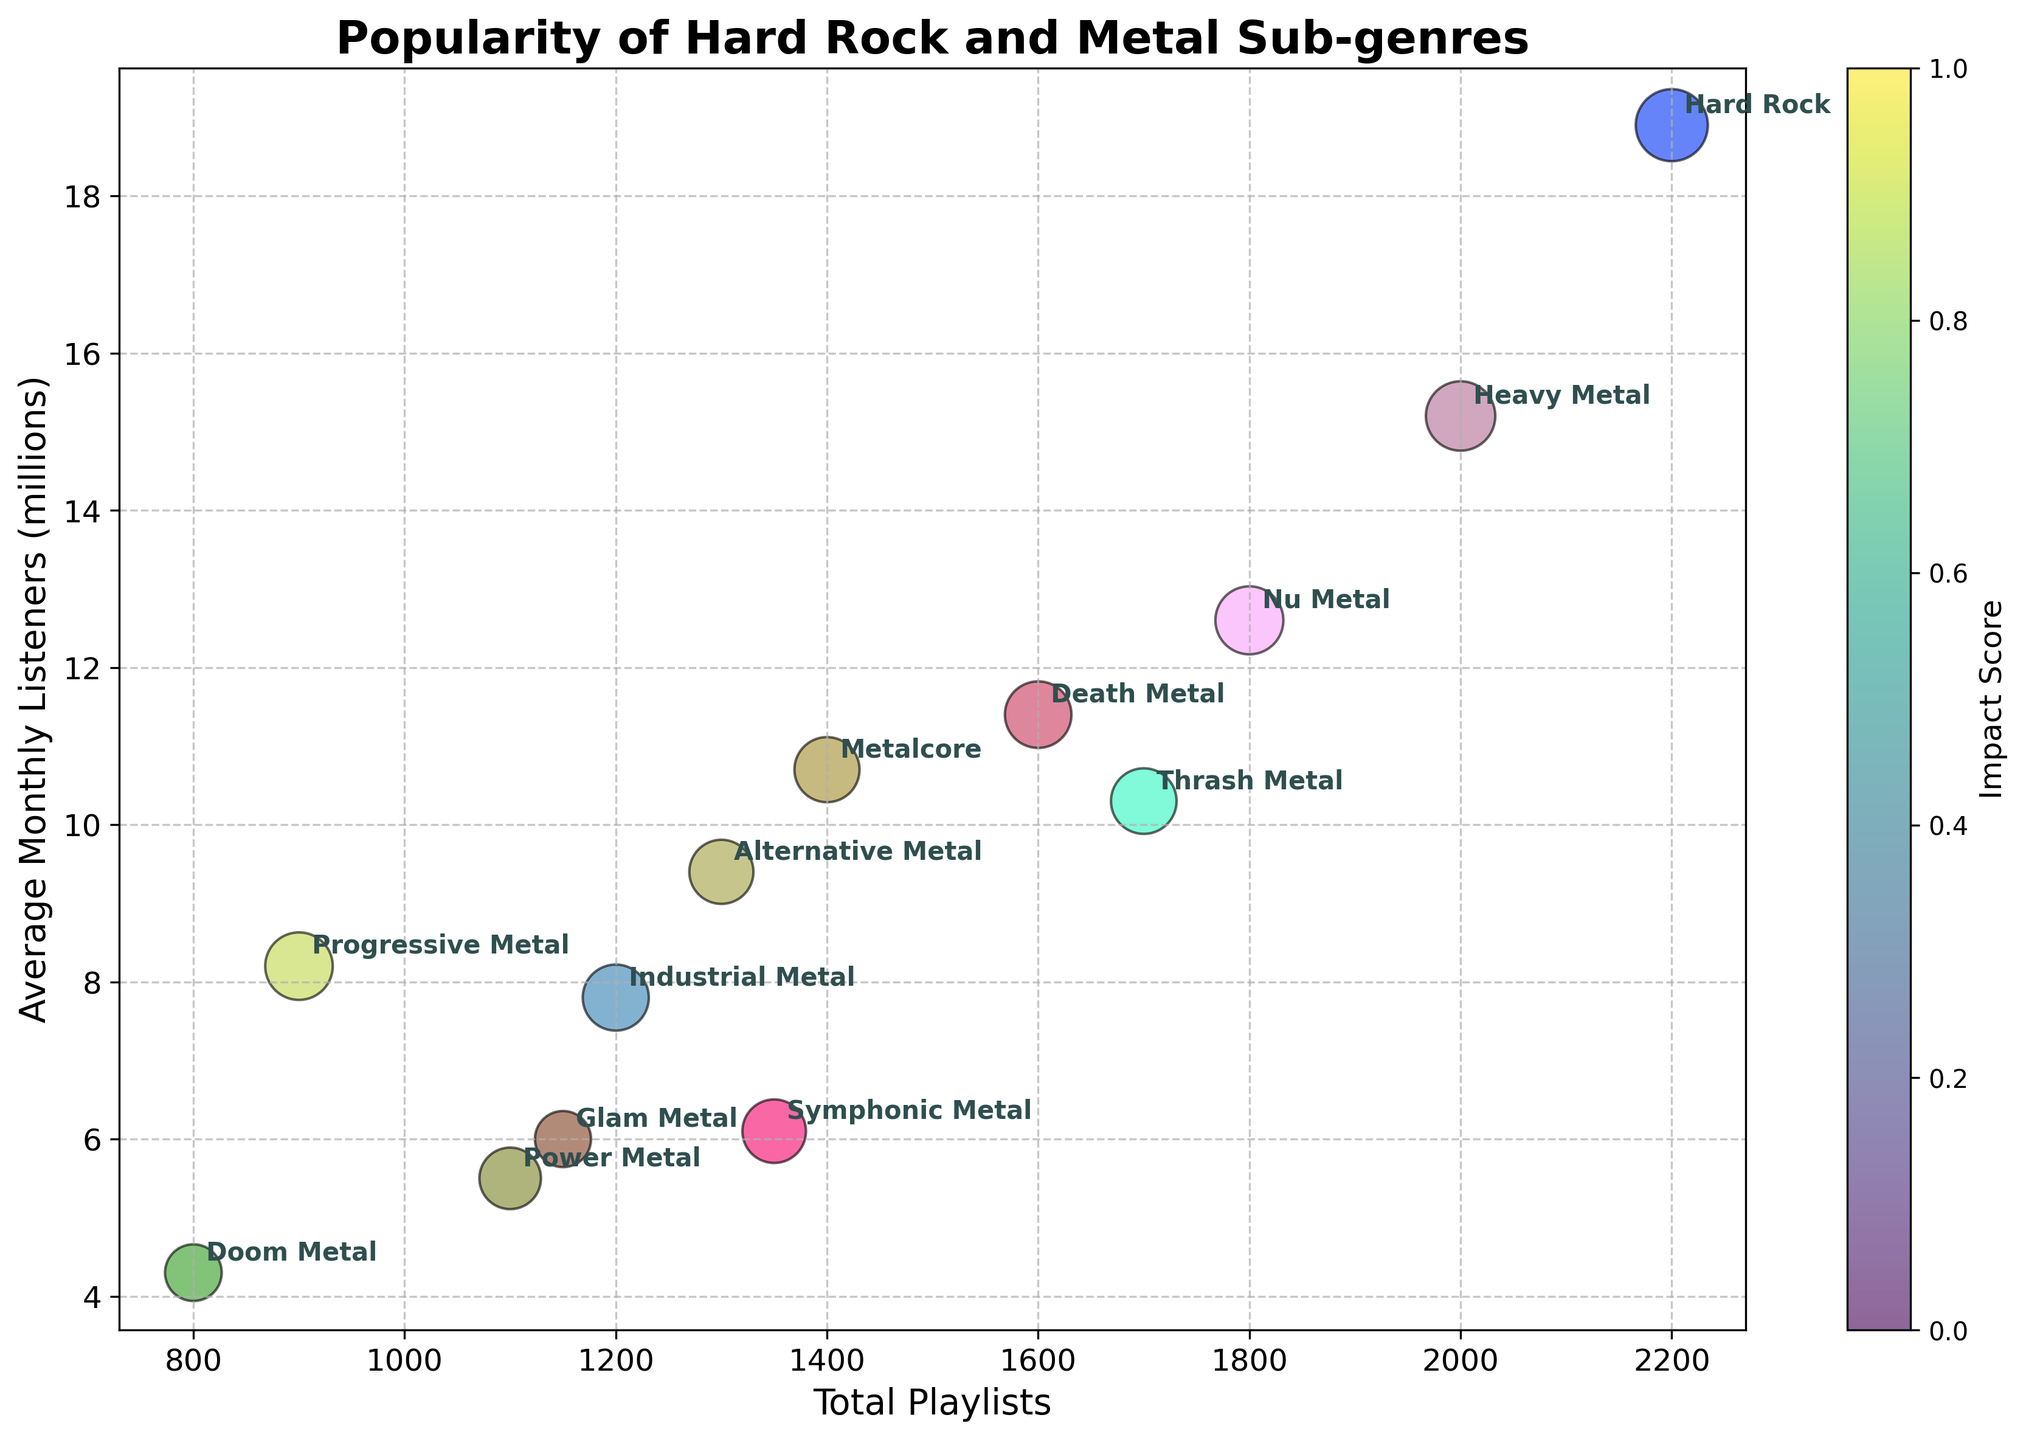What is the sub-genre with the highest average monthly listeners? Look for the bubble with the highest position on the y-axis, labeled with the sub-genre name. The bubble at the highest place on the y-axis is labeled Hard Rock.
Answer: Hard Rock How many sub-genres have an average monthly listeners count greater than 10 million? Identify bubbles above the 10 million mark on the y-axis. There are 5 such bubbles: Heavy Metal, Thrash Metal, Death Metal, Nu Metal, and Hard Rock.
Answer: 5 Which sub-genre has the smallest impact score and what is its value? Find the smallest bubble on the chart and read its label and corresponding impact score. The smallest bubble is Glam Metal, and its impact score is 4.9.
Answer: Glam Metal, 4.9 What is the average impact score of all sub-genres? Sum up all impact scores and divide by the number of sub-genres. Sum(7.5 + 6.8 + 6.3 + 5.9 + 6.7 + 7.1 + 6.9 + 7.2 + 8.1 + 6.4 + 4.9 + 6.6 + 5.0) = 87.4, and the count is 13. 87.4/13 = approximately 6.72.
Answer: ~6.72 How many sub-genres have more than 1500 playlists? Count bubbles that have a position on the x-axis greater than 1500. There are 4 bubbles: Heavy Metal, Nu Metal, Thrash Metal, and Hard Rock.
Answer: 4 Which sub-genre has more average monthly listeners: Industrial Metal or Progressive Metal? Compare the y-axis values of Industrial Metal (7.8 million) and Progressive Metal (8.2 million). Progressive Metal's y-axis value is higher.
Answer: Progressive Metal Which sub-genre is shown to have the highest impact score and how many playlists does it have? Look for the largest bubble and read its label and x-axis value. The largest bubble is Hard Rock with an impact score of 8.1 and 2200 playlists.
Answer: Hard Rock, 2200 playlists Is the total number of playlists for Power Metal more or less than that for Alternative Metal? Compare the x-axis values of Power Metal (1100) and Alternative Metal (1300). Alternative Metal has more playlists.
Answer: Less What is the sub-genre closest to having an average of 7 million monthly listeners? Find the bubble around the 7 million mark on the y-axis. The closest one is Industrial Metal with 7.8 million listeners.
Answer: Industrial Metal Which sub-genre has the smallest number of total playlists and what is its count? Find the leftmost bubble and read its x-axis value and label. The leftmost bubble is Doom Metal with 800 playlists.
Answer: Doom Metal, 800 